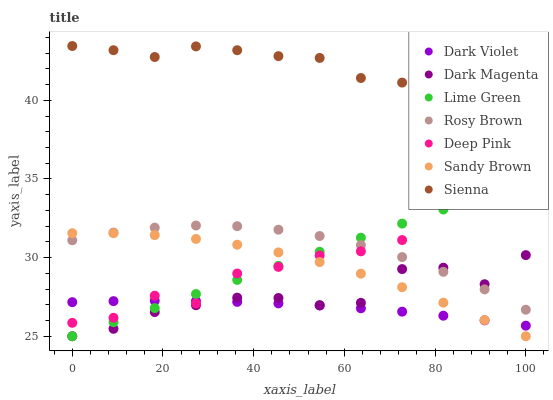Does Dark Violet have the minimum area under the curve?
Answer yes or no. Yes. Does Sienna have the maximum area under the curve?
Answer yes or no. Yes. Does Dark Magenta have the minimum area under the curve?
Answer yes or no. No. Does Dark Magenta have the maximum area under the curve?
Answer yes or no. No. Is Lime Green the smoothest?
Answer yes or no. Yes. Is Deep Pink the roughest?
Answer yes or no. Yes. Is Dark Magenta the smoothest?
Answer yes or no. No. Is Dark Magenta the roughest?
Answer yes or no. No. Does Dark Magenta have the lowest value?
Answer yes or no. Yes. Does Rosy Brown have the lowest value?
Answer yes or no. No. Does Sienna have the highest value?
Answer yes or no. Yes. Does Dark Magenta have the highest value?
Answer yes or no. No. Is Lime Green less than Sienna?
Answer yes or no. Yes. Is Sienna greater than Sandy Brown?
Answer yes or no. Yes. Does Dark Violet intersect Sandy Brown?
Answer yes or no. Yes. Is Dark Violet less than Sandy Brown?
Answer yes or no. No. Is Dark Violet greater than Sandy Brown?
Answer yes or no. No. Does Lime Green intersect Sienna?
Answer yes or no. No. 